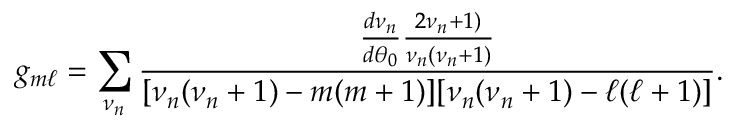Convert formula to latex. <formula><loc_0><loc_0><loc_500><loc_500>g _ { m \ell } = \sum _ { \nu _ { n } } \frac { \frac { d \nu _ { n } } { d \theta _ { 0 } } \frac { 2 \nu _ { n } + 1 ) } { \nu _ { n } ( \nu _ { n } + 1 ) } } { [ \nu _ { n } ( \nu _ { n } + 1 ) - m ( m + 1 ) ] [ \nu _ { n } ( \nu _ { n } + 1 ) - \ell ( \ell + 1 ) ] } .</formula> 